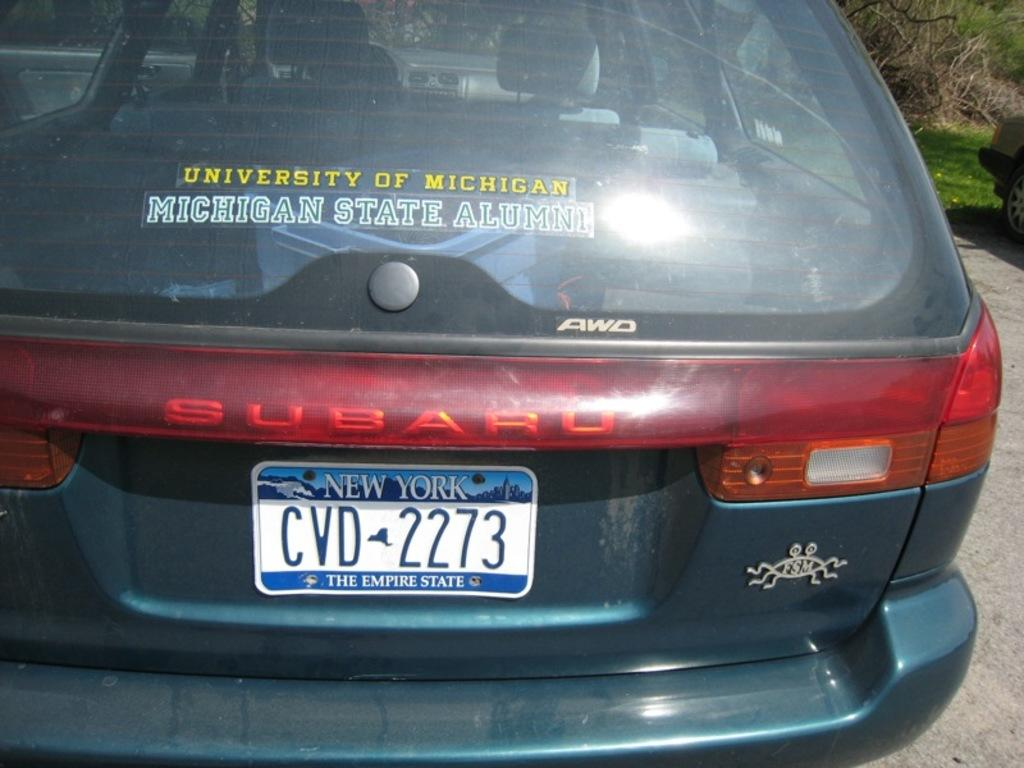Provide a one-sentence caption for the provided image. Car that is Subaru with a New York the empire state tag. 